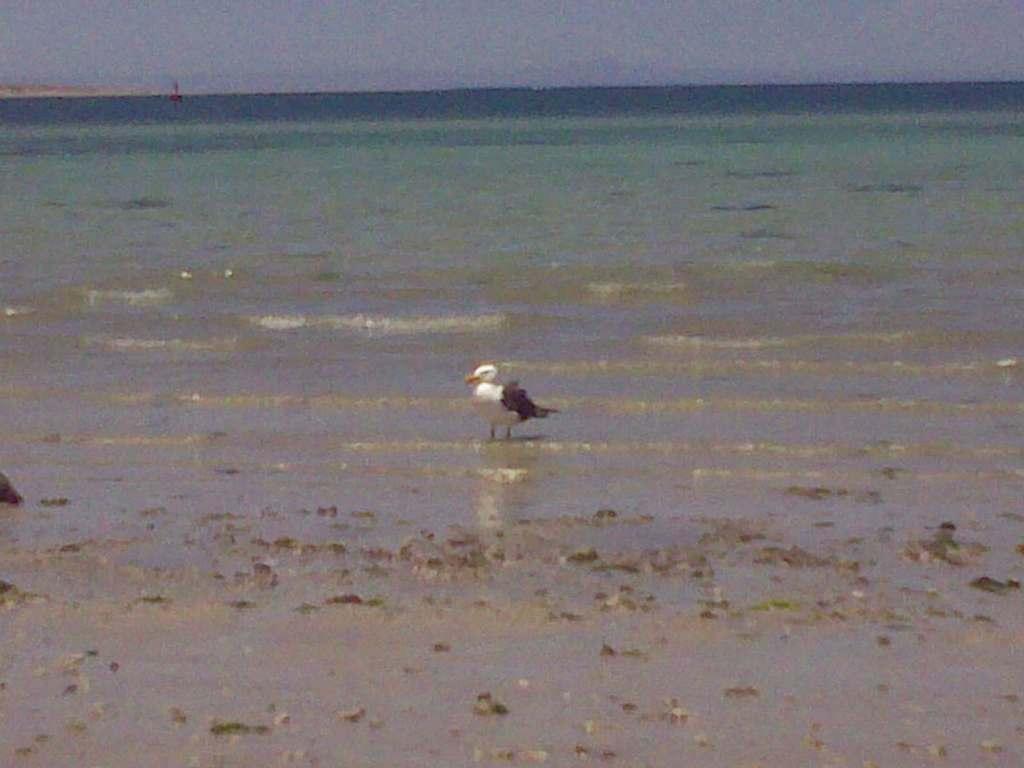Can you describe this image briefly? In this image, we can see a duck near the seashore. Here we can see a mud. Top of the image, there is a sea and sky we can see. 